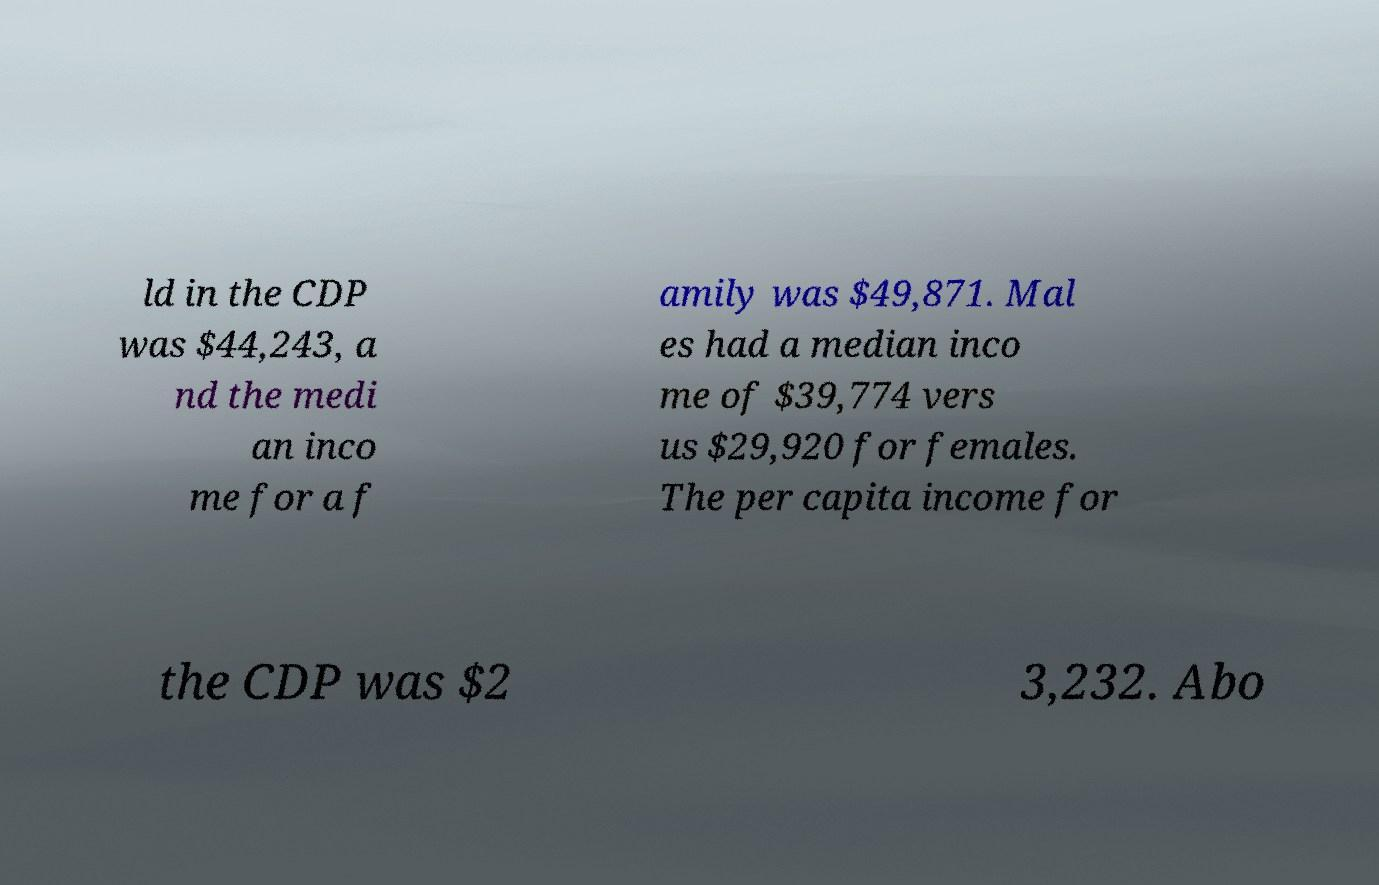Please read and relay the text visible in this image. What does it say? ld in the CDP was $44,243, a nd the medi an inco me for a f amily was $49,871. Mal es had a median inco me of $39,774 vers us $29,920 for females. The per capita income for the CDP was $2 3,232. Abo 